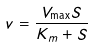<formula> <loc_0><loc_0><loc_500><loc_500>v = \frac { V _ { \max } S } { K _ { m } + S }</formula> 